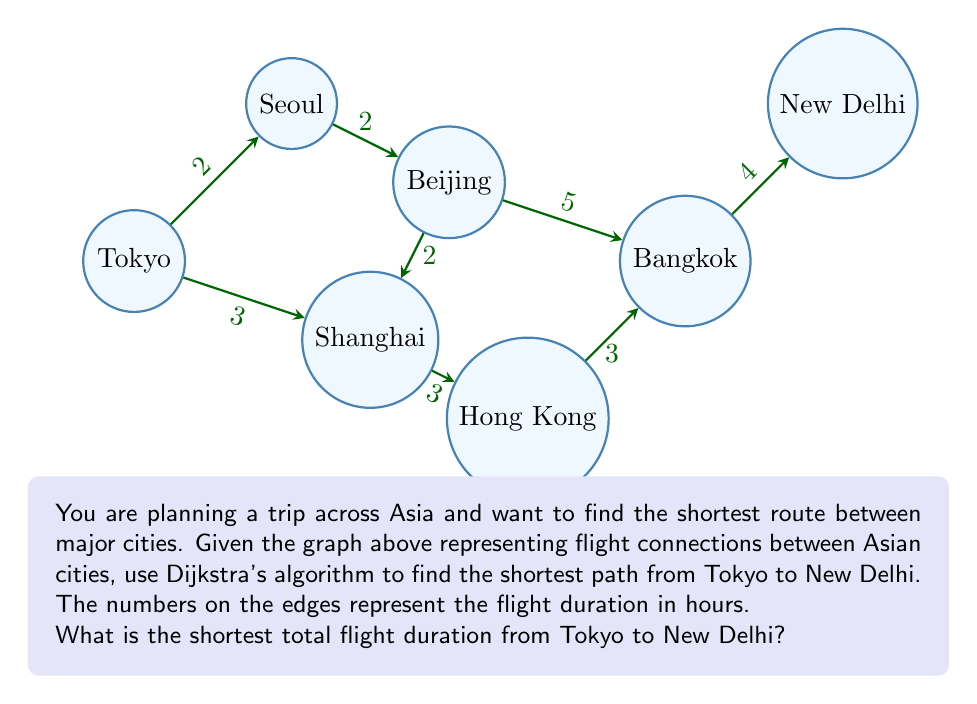Could you help me with this problem? Let's apply Dijkstra's algorithm to find the shortest path from Tokyo to New Delhi:

1) Initialize:
   - Set Tokyo's distance to 0 and all other cities to infinity.
   - Mark all cities as unvisited.

2) Start with Tokyo:
   - Update distances: Seoul (2), Shanghai (3)
   - Mark Tokyo as visited

3) Choose the unvisited city with the smallest distance (Seoul, 2):
   - Update: Beijing (2 + 2 = 4)
   - Mark Seoul as visited

4) Choose Shanghai (3):
   - Update: Hong Kong (3 + 3 = 6)
   - Mark Shanghai as visited

5) Choose Beijing (4):
   - Update: Bangkok (4 + 5 = 9)
   - Mark Beijing as visited

6) Choose Hong Kong (6):
   - Update: Bangkok (6 + 3 = 9, no change)
   - Mark Hong Kong as visited

7) Choose Bangkok (9):
   - Update: New Delhi (9 + 4 = 13)
   - Mark Bangkok as visited

8) New Delhi is reached with a total distance of 13 hours.

The shortest path is: Tokyo → Shanghai → Hong Kong → Bangkok → New Delhi

Total flight duration: $3 + 3 + 3 + 4 = 13$ hours
Answer: 13 hours 